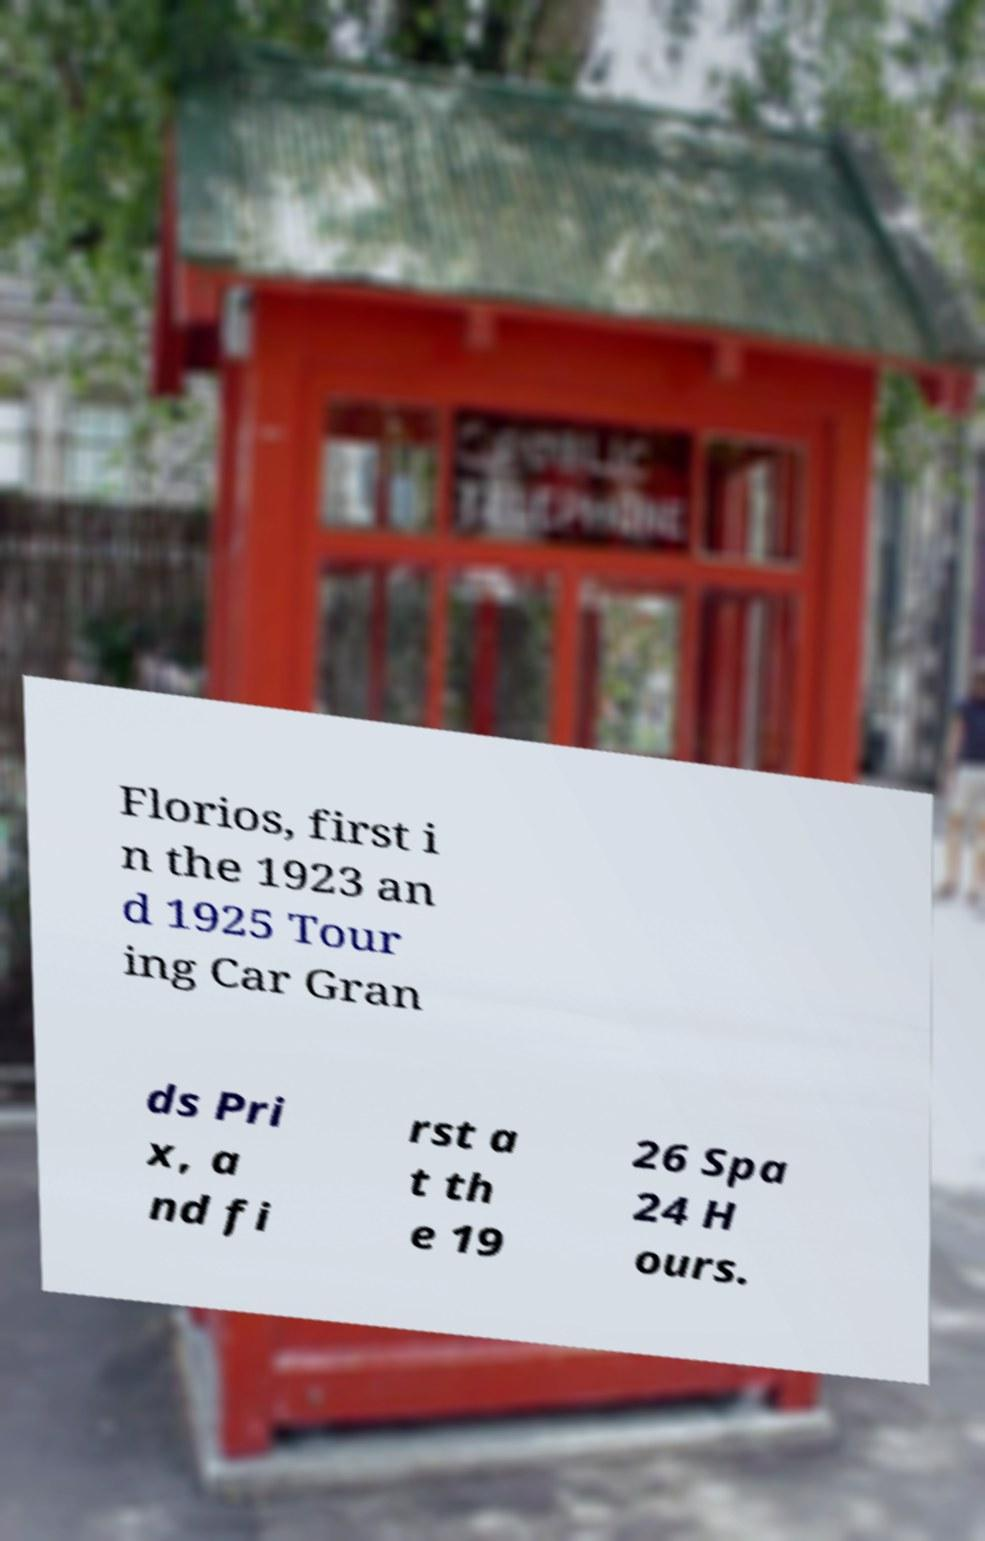For documentation purposes, I need the text within this image transcribed. Could you provide that? Florios, first i n the 1923 an d 1925 Tour ing Car Gran ds Pri x, a nd fi rst a t th e 19 26 Spa 24 H ours. 